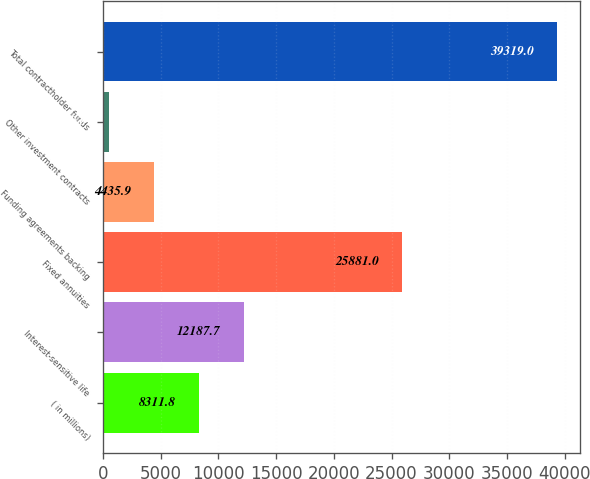Convert chart. <chart><loc_0><loc_0><loc_500><loc_500><bar_chart><fcel>( in millions)<fcel>Interest-sensitive life<fcel>Fixed annuities<fcel>Funding agreements backing<fcel>Other investment contracts<fcel>Total contractholder funds<nl><fcel>8311.8<fcel>12187.7<fcel>25881<fcel>4435.9<fcel>560<fcel>39319<nl></chart> 